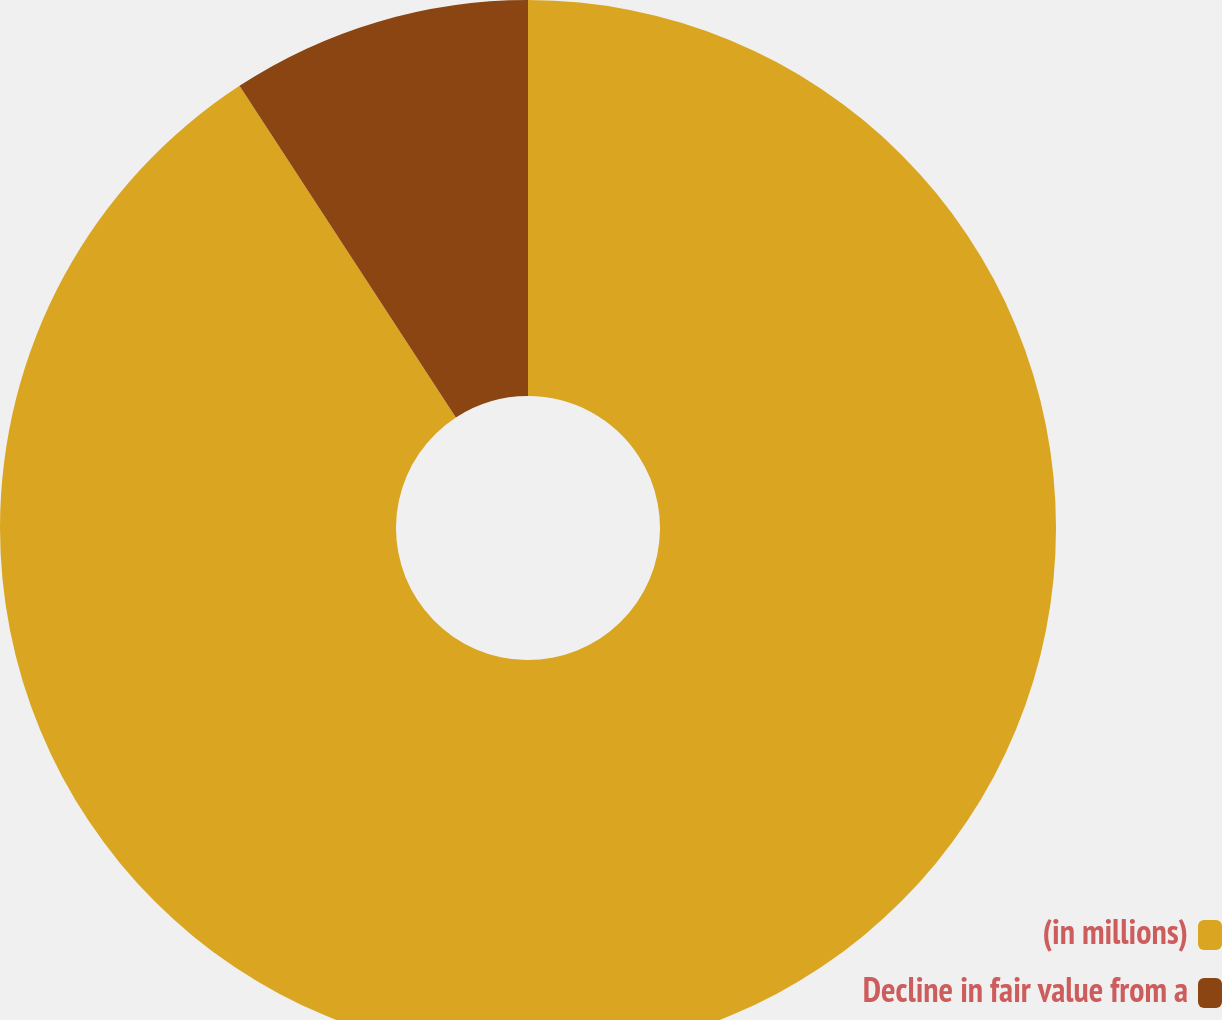Convert chart to OTSL. <chart><loc_0><loc_0><loc_500><loc_500><pie_chart><fcel>(in millions)<fcel>Decline in fair value from a<nl><fcel>90.8%<fcel>9.2%<nl></chart> 